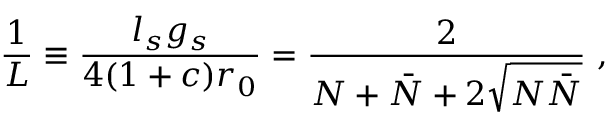Convert formula to latex. <formula><loc_0><loc_0><loc_500><loc_500>\frac { 1 } { L } \equiv \frac { l _ { s } g _ { s } } { 4 ( 1 + c ) r _ { 0 } } = \frac { 2 } { N + \bar { N } + 2 \sqrt { N \bar { N } } } ,</formula> 